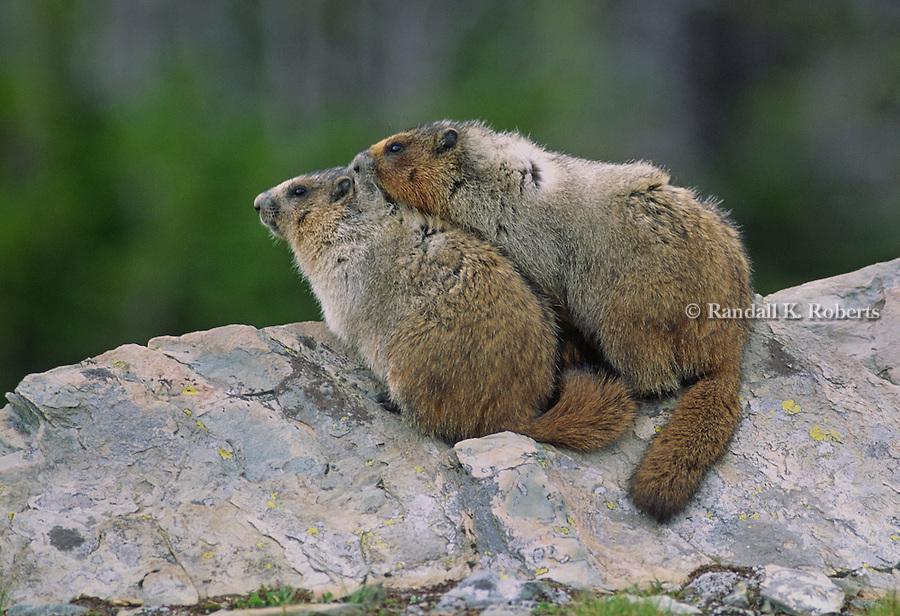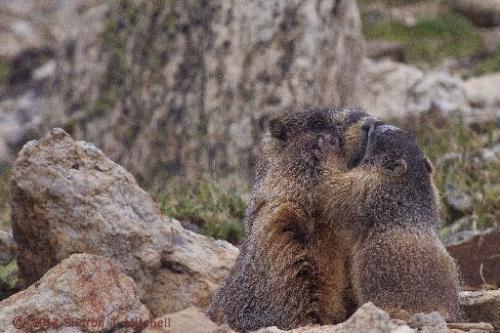The first image is the image on the left, the second image is the image on the right. Evaluate the accuracy of this statement regarding the images: "Each image contains one pair of marmots posed close together on a rock, and no marmots have their backs to the camera.". Is it true? Answer yes or no. No. The first image is the image on the left, the second image is the image on the right. Evaluate the accuracy of this statement regarding the images: "On the right image, the two animals are facing the same direction.". Is it true? Answer yes or no. No. 